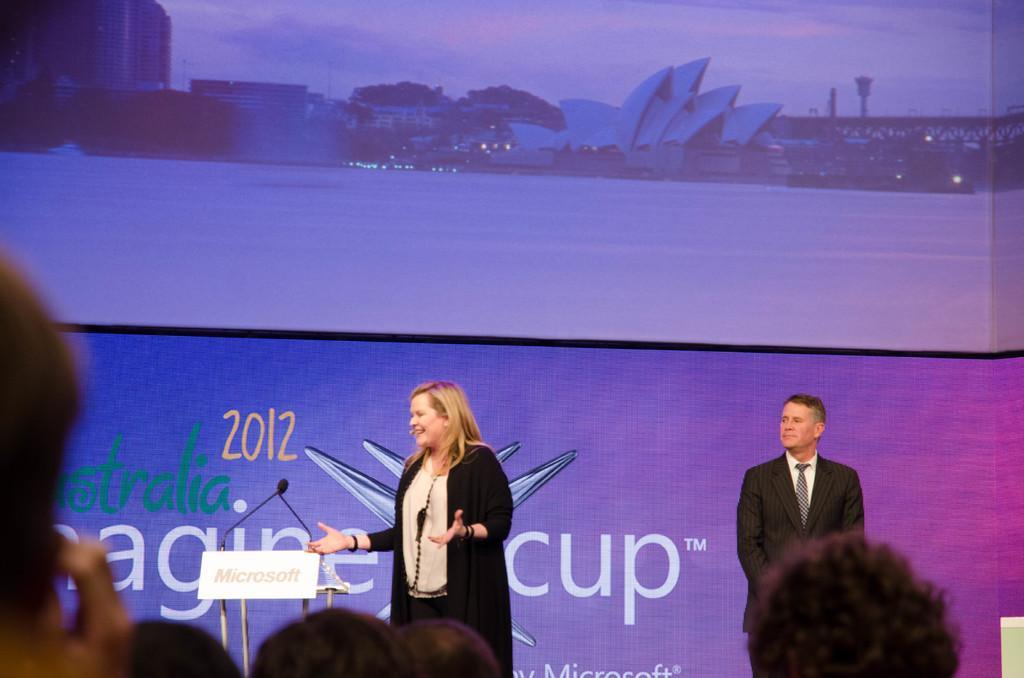How would you summarize this image in a sentence or two? In this picture couple of them standing and I can see few people at the bottom of the picture and looks like a screen in the background. I can see text and a podium with couple of microphones. 